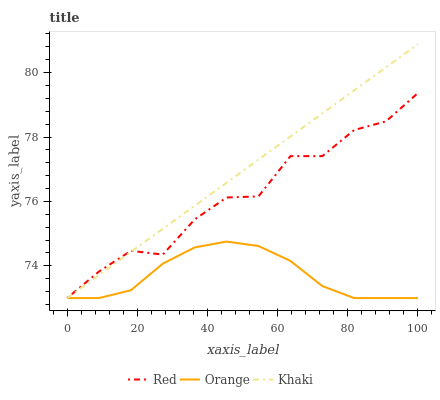Does Red have the minimum area under the curve?
Answer yes or no. No. Does Red have the maximum area under the curve?
Answer yes or no. No. Is Red the smoothest?
Answer yes or no. No. Is Khaki the roughest?
Answer yes or no. No. Does Red have the highest value?
Answer yes or no. No. 